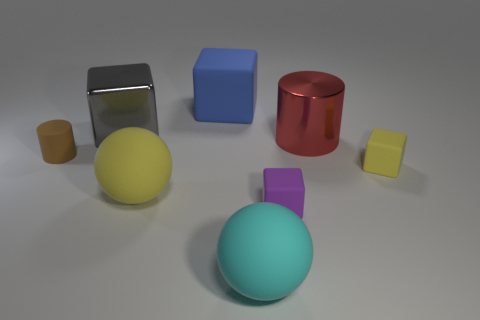If you had to guess, what might be the purpose of arranging these objects in such a manner? This arrangement of objects might serve several purposes. It could be part of a visual study exploring form and color, a set-up for a 3D rendering test showcasing different textures and lighting effects, or perhaps an artistic composition aimed at capturing balance and contrast between geometric shapes. 